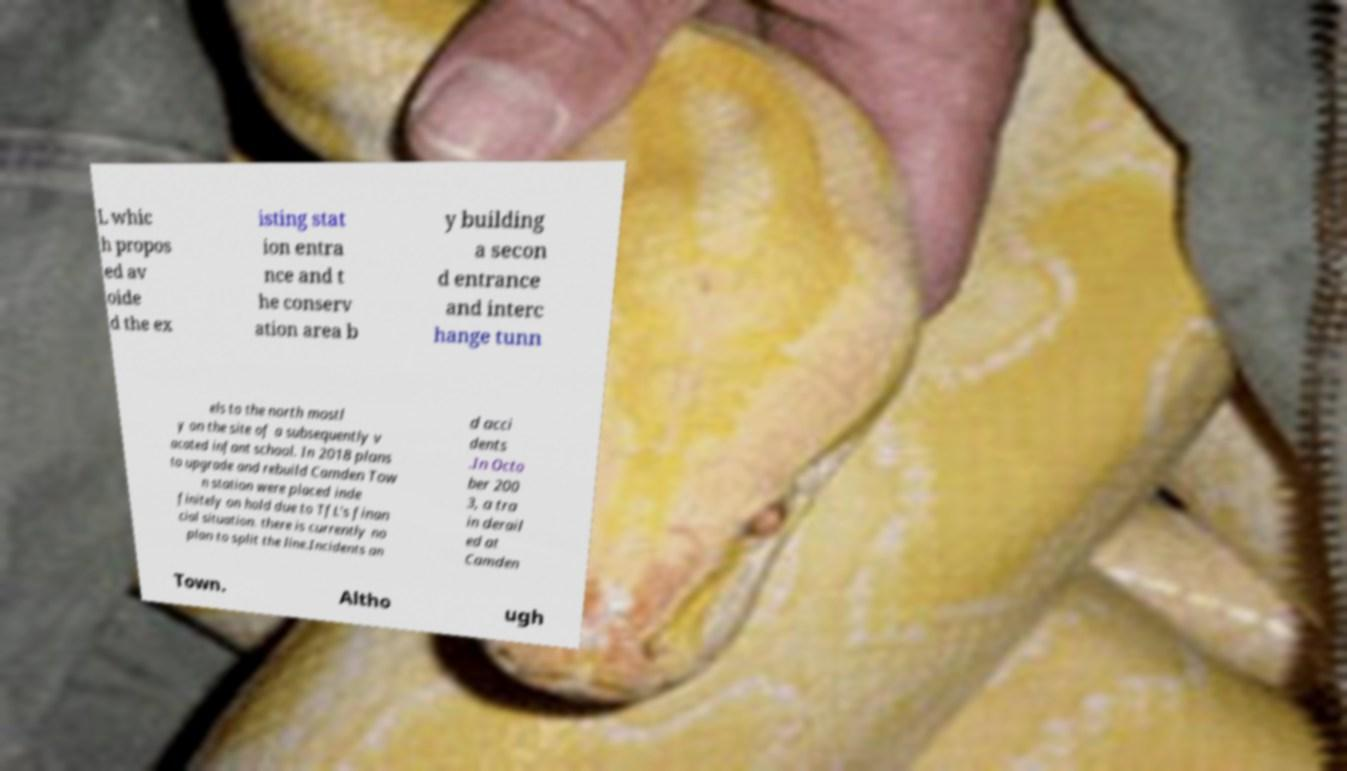Could you extract and type out the text from this image? L whic h propos ed av oide d the ex isting stat ion entra nce and t he conserv ation area b y building a secon d entrance and interc hange tunn els to the north mostl y on the site of a subsequently v acated infant school. In 2018 plans to upgrade and rebuild Camden Tow n station were placed inde finitely on hold due to TfL's finan cial situation. there is currently no plan to split the line.Incidents an d acci dents .In Octo ber 200 3, a tra in derail ed at Camden Town. Altho ugh 